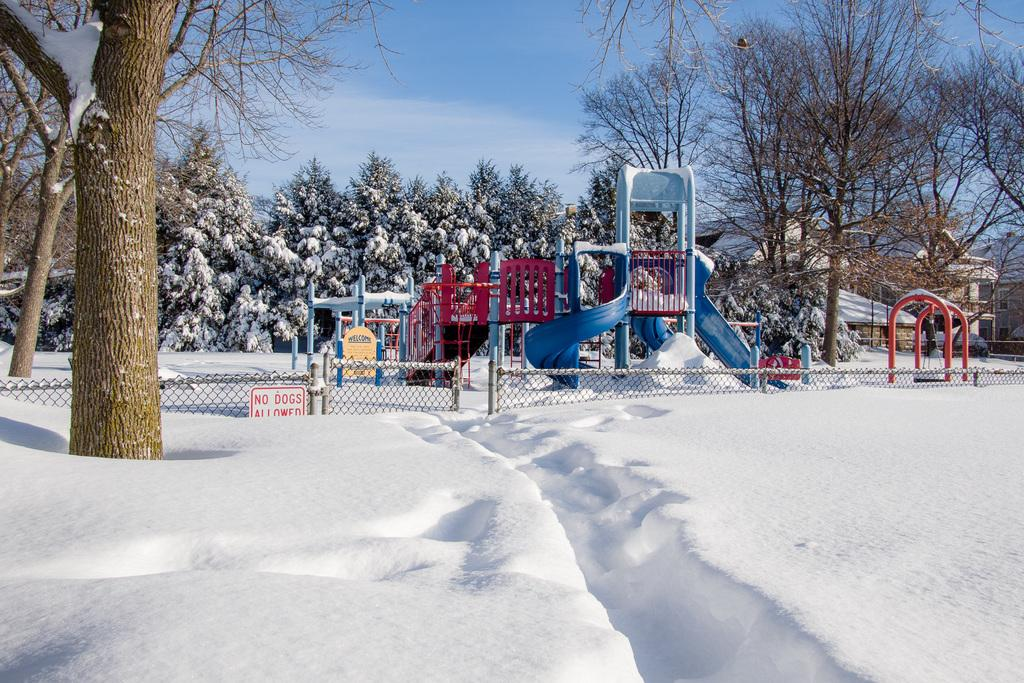What is covering the ground in the foreground of the image? There is snow in the foreground of the image. What type of playground equipment can be seen in the image? There are slides in the image. What is used to separate the play area in the image? There is a net boundary in the image. What type of vegetation is present in the image? There are trees in the image. What can be seen in the distance in the image? There are houses visible in the background of the image, and the sky is visible as well. What type of ink can be seen dripping from the trees in the image? There is no ink present in the image; it features snow, slides, a net boundary, trees, houses, and the sky. How does the regret manifest itself in the image? There is no mention of regret in the image, as it focuses on the snow, slides, net boundary, trees, houses, and the sky. 